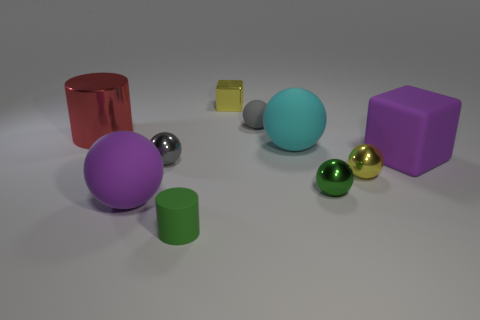There is a gray thing to the right of the metallic thing behind the tiny gray rubber sphere; what is its size?
Provide a succinct answer. Small. How many things are small things that are right of the tiny gray metallic ball or big things that are on the right side of the matte cylinder?
Make the answer very short. 7. Is the number of green metal balls less than the number of yellow things?
Ensure brevity in your answer.  Yes. What number of things are tiny brown blocks or small yellow things?
Provide a short and direct response. 2. Is the tiny gray matte thing the same shape as the small green rubber thing?
Provide a short and direct response. No. Are there any other things that have the same material as the purple ball?
Offer a terse response. Yes. Does the gray thing that is behind the red metal object have the same size as the block left of the green shiny object?
Provide a short and direct response. Yes. There is a large object that is behind the large purple rubber ball and to the left of the cyan object; what is its material?
Your answer should be compact. Metal. Is there anything else of the same color as the small metallic cube?
Offer a terse response. Yes. Are there fewer shiny cubes in front of the big cyan rubber sphere than big cyan things?
Your answer should be compact. Yes. 